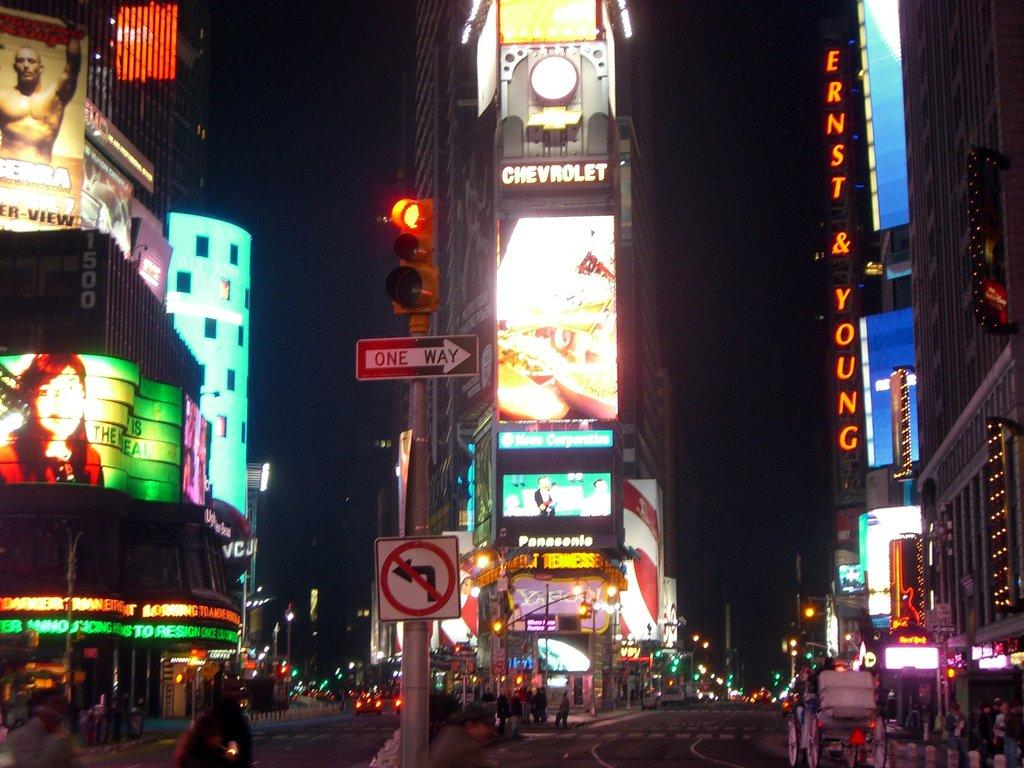<image>
Present a compact description of the photo's key features. Ernst and young sign on a street and one way sign under a traffic light. 